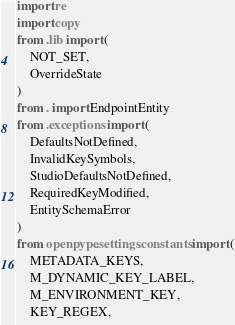Convert code to text. <code><loc_0><loc_0><loc_500><loc_500><_Python_>import re
import copy
from .lib import (
    NOT_SET,
    OverrideState
)
from . import EndpointEntity
from .exceptions import (
    DefaultsNotDefined,
    InvalidKeySymbols,
    StudioDefaultsNotDefined,
    RequiredKeyModified,
    EntitySchemaError
)
from openpype.settings.constants import (
    METADATA_KEYS,
    M_DYNAMIC_KEY_LABEL,
    M_ENVIRONMENT_KEY,
    KEY_REGEX,</code> 